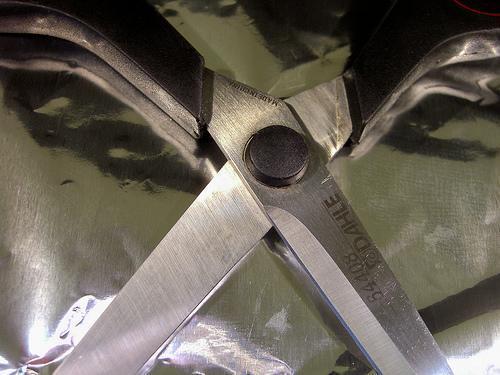How many blades are there?
Give a very brief answer. 2. 